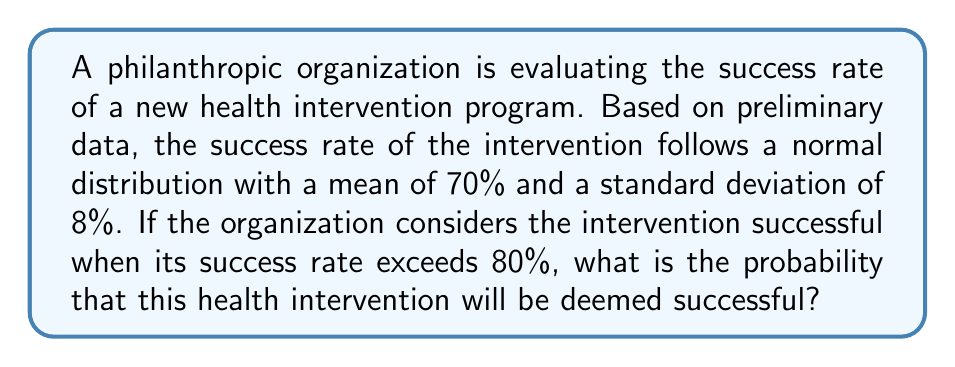Provide a solution to this math problem. To solve this problem, we need to follow these steps:

1. Identify the given information:
   - The success rate follows a normal distribution
   - Mean (μ) = 70%
   - Standard deviation (σ) = 8%
   - We want to find P(X > 80%), where X is the success rate

2. Calculate the z-score for the threshold value (80%):
   $$z = \frac{x - \mu}{\sigma} = \frac{80 - 70}{8} = 1.25$$

3. Use the standard normal distribution table or a calculator to find the area to the right of z = 1.25. This area represents the probability we're looking for.

4. The area to the right of z = 1.25 is equal to 1 minus the area to the left of z = 1.25.
   Area to the left of z = 1.25 ≈ 0.8944 (from standard normal table)

5. Calculate the final probability:
   $$P(X > 80\%) = 1 - 0.8944 = 0.1056$$

Therefore, the probability that the health intervention will be deemed successful (i.e., have a success rate exceeding 80%) is approximately 0.1056 or 10.56%.
Answer: 0.1056 